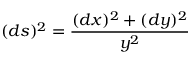Convert formula to latex. <formula><loc_0><loc_0><loc_500><loc_500>( d s ) ^ { 2 } = { \frac { ( d x ) ^ { 2 } + ( d y ) ^ { 2 } } { y ^ { 2 } } }</formula> 